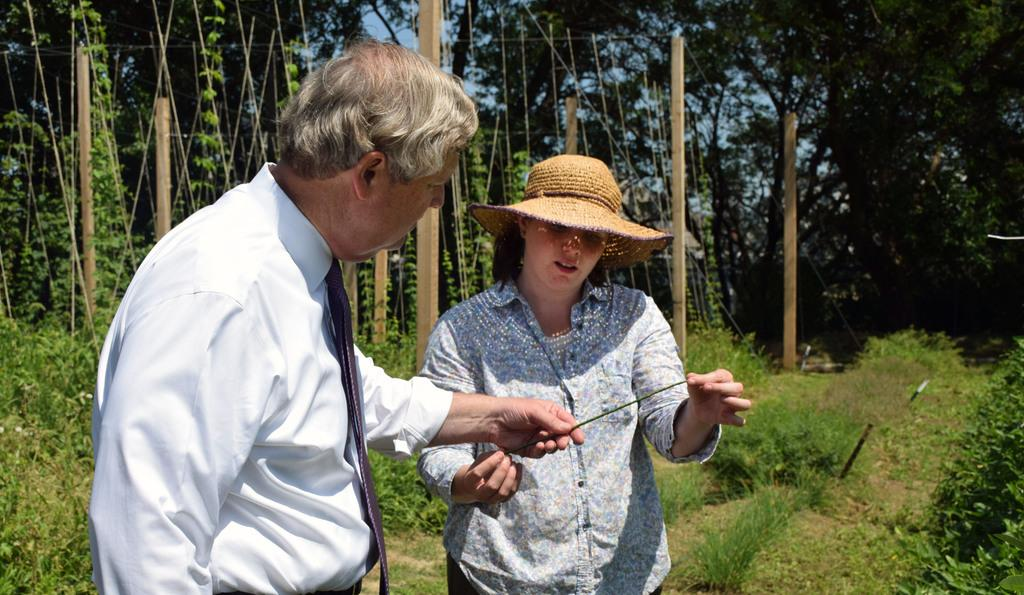How many people are present in the image? There are two people, a man and a woman, present in the image. What are the man and woman doing in the image? They are standing on the land and holding a stem. What type of vegetation can be seen in the image? There is grass, plants, and trees visible in the image. What is the background of the image? The background of the image includes wooden poles and the sky. How does the crowd react to the cattle in the image? There is no crowd or cattle present in the image; it features a man and a woman standing on the land and holding a stem. 